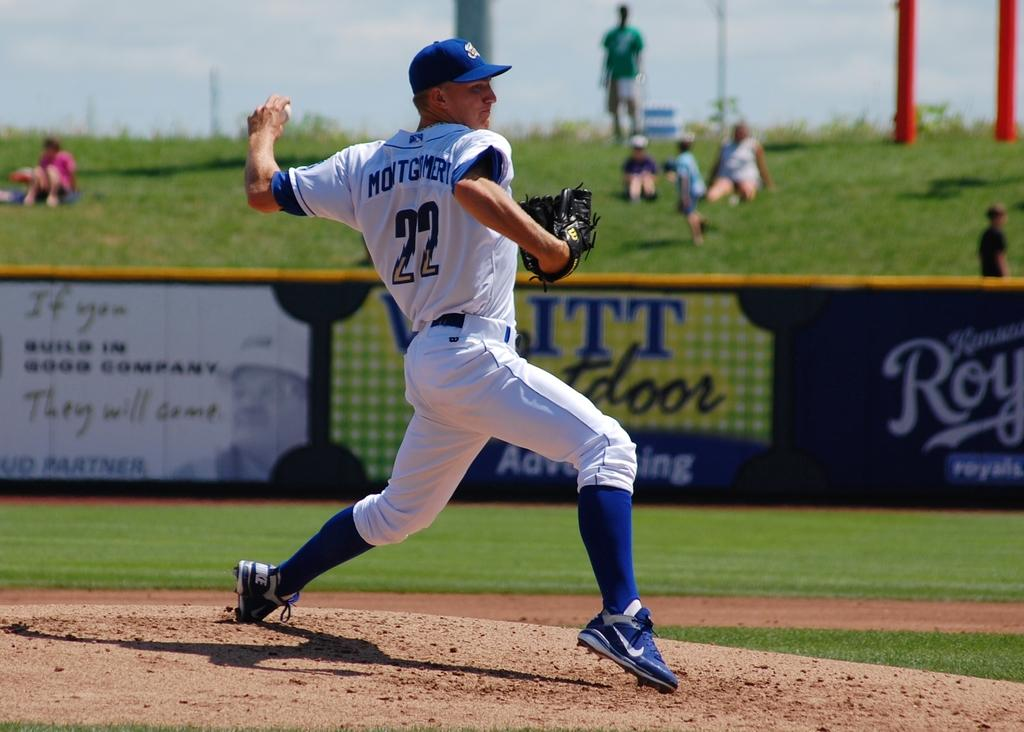<image>
Offer a succinct explanation of the picture presented. A baseball player, wearing the number 22, gets ready to throw the ball. 